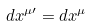Convert formula to latex. <formula><loc_0><loc_0><loc_500><loc_500>d x ^ { \mu \prime } = d x ^ { \mu }</formula> 